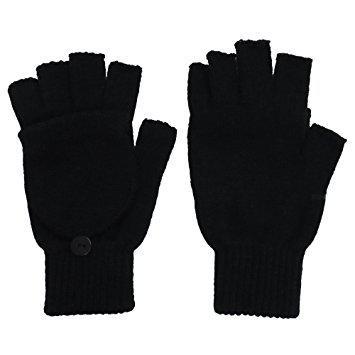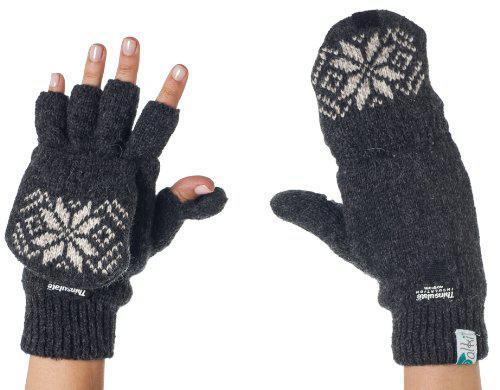The first image is the image on the left, the second image is the image on the right. Given the left and right images, does the statement "In one of the images, human fingers are visible in only one of the two gloves." hold true? Answer yes or no. Yes. The first image is the image on the left, the second image is the image on the right. Considering the images on both sides, is "The right image shows a pair of gloves modeled on human hands, with one glove displaying fingers while the other glove is covered" valid? Answer yes or no. Yes. 